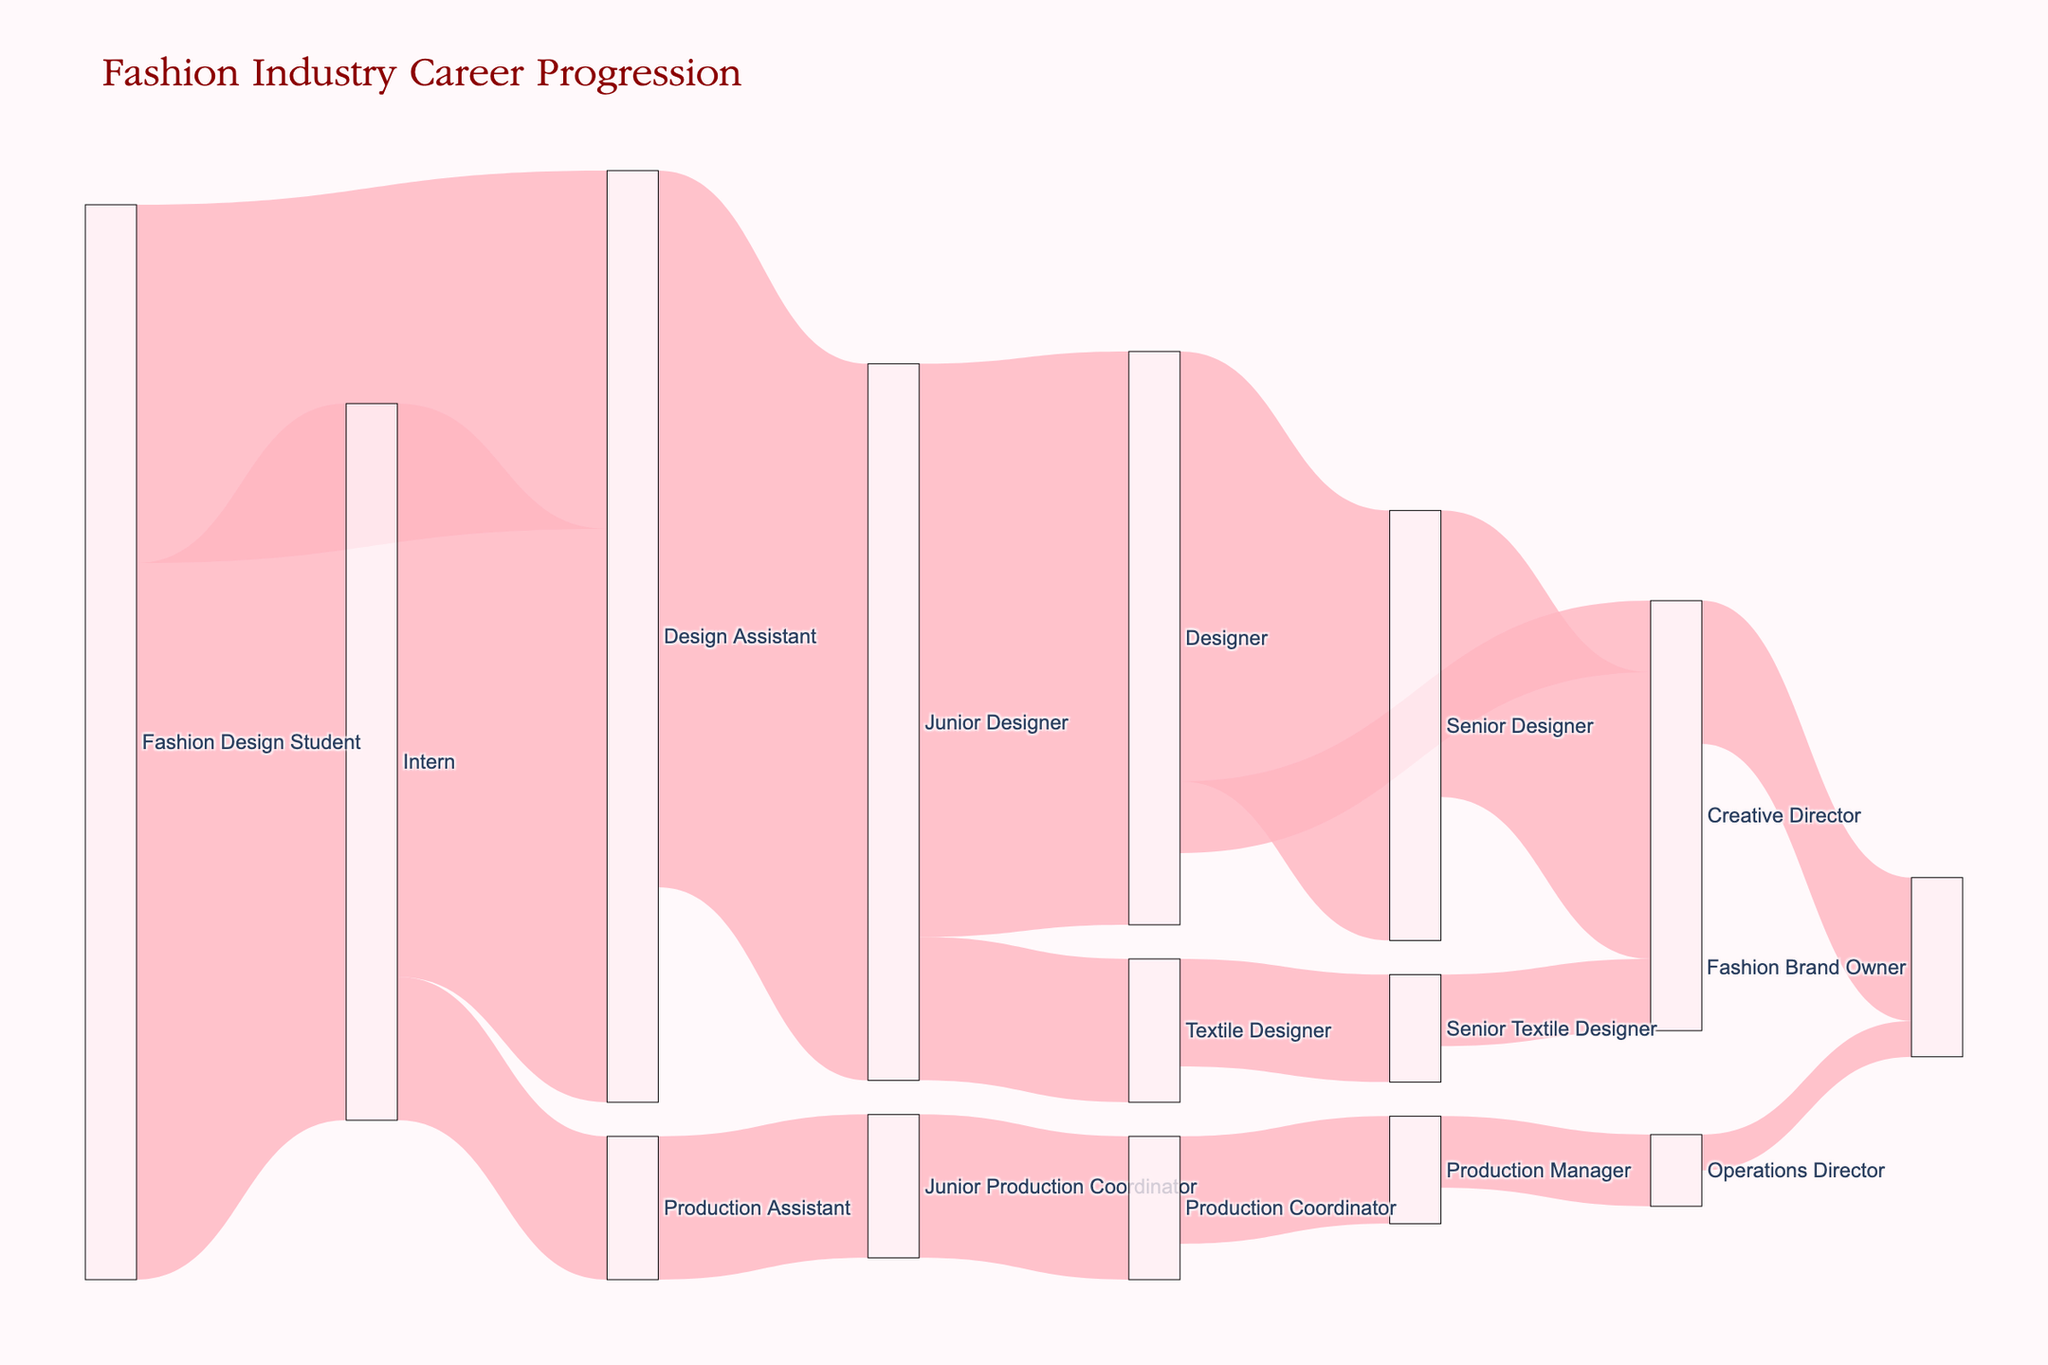what's the title of the figure? The title is usually shown at the top of the figure, reflecting its main theme.
Answer: Fashion Industry Career Progression How many career progression paths start from an Intern position? To determine this, count the number of outgoing flows from the "Intern" node in the Sankey diagram.
Answer: 2 Which career path has the highest number of people starting from a Fashion Design Student position? Compare the outgoing values from the "Fashion Design Student" node to see which one is the largest.
Answer: Intern (100) What is the total number of people that eventually become a Designer? Sum the values leading to the "Designer" node. Here, we add the values from paths "Junior Designer -> Designer" (80).
Answer: 80 How many people transition directly from Designer to Creative Director? Find the value of the flow directly connecting "Designer" to "Creative Director".
Answer: 10 Between the paths from Designer to Senior Designer and from Designer to Creative Director, which has more people? Compare the values of the flows "Designer -> Senior Designer" and "Designer -> Creative Director".
Answer: Senior Designer (60) What is the end position for someone who starts as a Production Assistant? Trace the subsequent steps from "Production Assistant" to see the eventual end nodes. The path is "Production Assistant -> Junior Production Coordinator -> Production Coordinator -> Production Manager -> Operations Director -> Fashion Brand Owner".
Answer: Fashion Brand Owner What is the total number of direct transitions to Creative Director? Sum the values of all flows directly entering the "Creative Director" node: "Senior Designer -> Creative Director" (40) and "Senior Textile Designer -> Creative Director" (10).
Answer: 50 Is it more common for a Junior Designer to become a Textile Designer or a Designer? Compare the values of flows from "Junior Designer" leading to "Textile Designer" and "Designer".
Answer: Designer (80) 